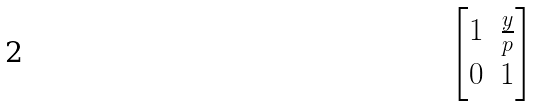<formula> <loc_0><loc_0><loc_500><loc_500>\begin{bmatrix} 1 & \frac { y } { p } \\ 0 & 1 \end{bmatrix}</formula> 